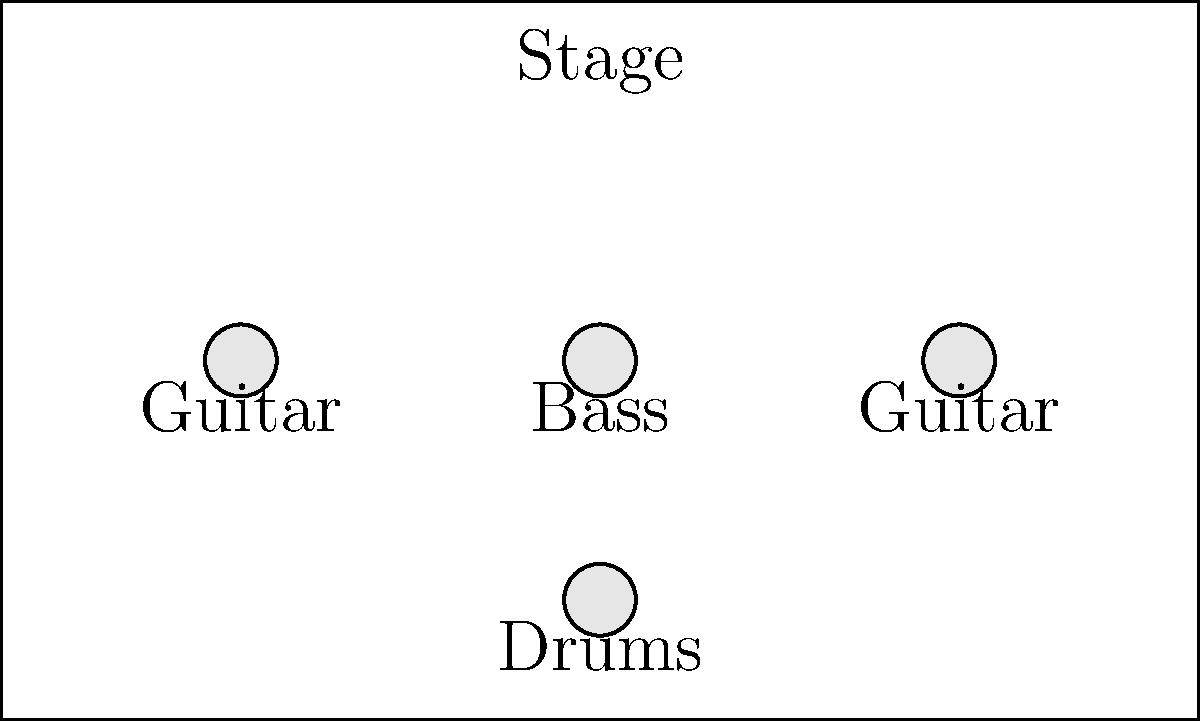Based on the stage layout diagram for Rancid's recent tour, match the following band members to their correct positions:

1. Tim Armstrong
2. Lars Frederiksen
3. Matt Freeman
4. Branden Steineckert

Which number corresponds to the bassist's position on stage? To solve this problem, we need to follow these steps:

1. Recall the typical instrument assignments for Rancid band members:
   - Tim Armstrong: Lead vocals, guitar
   - Lars Frederiksen: Guitar, vocals
   - Matt Freeman: Bass
   - Branden Steineckert: Drums

2. Analyze the stage layout diagram:
   - There are four positions marked on the stage.
   - Three positions are in a line at the front of the stage, labeled "Guitar," "Bass," and "Guitar."
   - One position is at the back of the stage, labeled "Drums."

3. Match the band members to their instruments and positions:
   - The drummer, Branden Steineckert, would be at the back of the stage (position 4).
   - The bassist, Matt Freeman, would be in the middle of the front line (position 2).
   - The two guitarists, Tim Armstrong and Lars Frederiksen, would be on either side of the bassist (positions 1 and 3).

4. Identify the number corresponding to the bassist's position:
   - The bassist (Matt Freeman) is in position 2, which is in the middle of the front line.

Therefore, the number corresponding to the bassist's position on stage is 2.
Answer: 2 